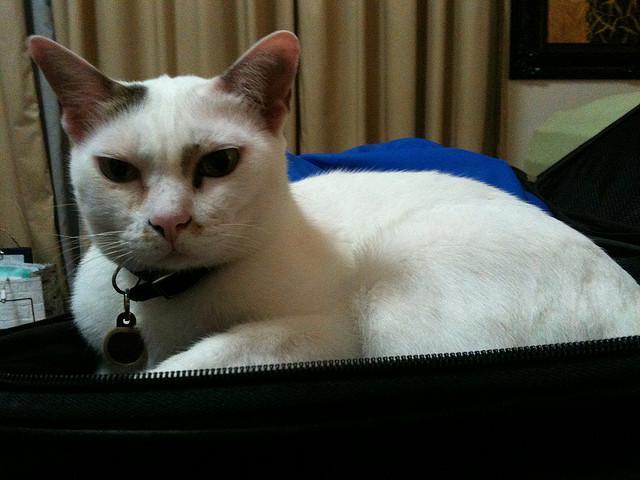How many baskets are on the dresser?
Give a very brief answer. 0. 